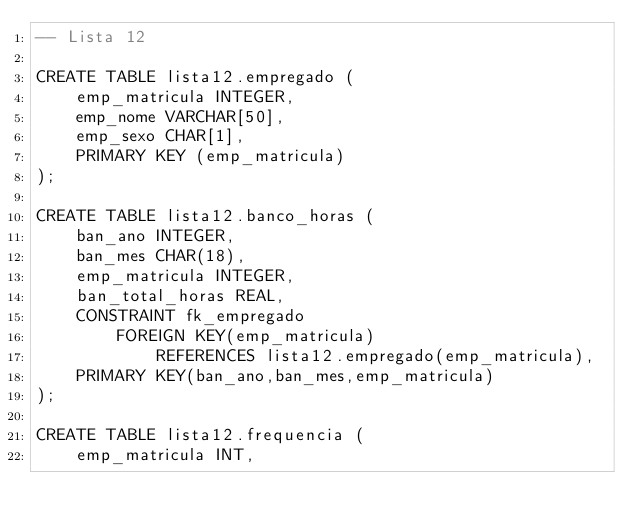<code> <loc_0><loc_0><loc_500><loc_500><_SQL_>-- Lista 12

CREATE TABLE lista12.empregado (
	emp_matricula INTEGER,
	emp_nome VARCHAR[50],
	emp_sexo CHAR[1],
	PRIMARY KEY (emp_matricula)
);

CREATE TABLE lista12.banco_horas (
	ban_ano INTEGER,
	ban_mes CHAR(18),
	emp_matricula INTEGER,
	ban_total_horas REAL,
	CONSTRAINT fk_empregado
		FOREIGN KEY(emp_matricula)
			REFERENCES lista12.empregado(emp_matricula),
	PRIMARY KEY(ban_ano,ban_mes,emp_matricula)
);

CREATE TABLE lista12.frequencia (
	emp_matricula INT,</code> 